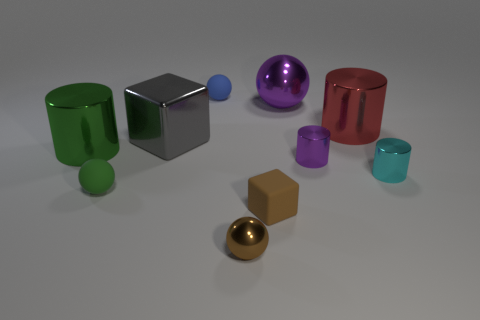Subtract all small shiny spheres. How many spheres are left? 3 Subtract all green spheres. How many spheres are left? 3 Subtract all blocks. How many objects are left? 8 Add 7 blue balls. How many blue balls are left? 8 Add 4 large metallic cubes. How many large metallic cubes exist? 5 Subtract 0 gray balls. How many objects are left? 10 Subtract 1 cylinders. How many cylinders are left? 3 Subtract all blue balls. Subtract all blue cylinders. How many balls are left? 3 Subtract all purple balls. How many gray cubes are left? 1 Subtract all large purple objects. Subtract all large cubes. How many objects are left? 8 